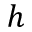Convert formula to latex. <formula><loc_0><loc_0><loc_500><loc_500>h</formula> 